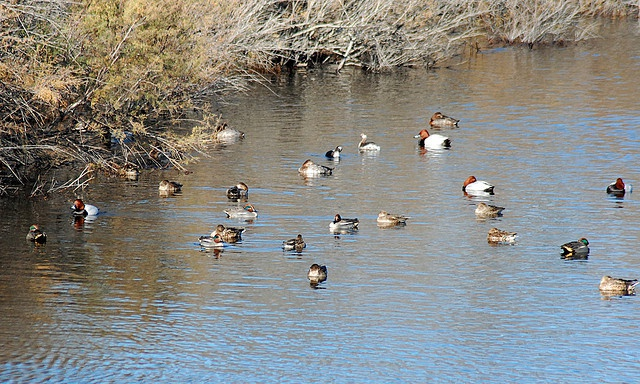Describe the objects in this image and their specific colors. I can see bird in olive, darkgray, black, and gray tones, bird in olive, tan, ivory, and darkgray tones, bird in olive, white, black, darkgray, and gray tones, bird in olive, lightgray, darkgray, gray, and black tones, and bird in olive, white, black, darkgray, and maroon tones in this image. 